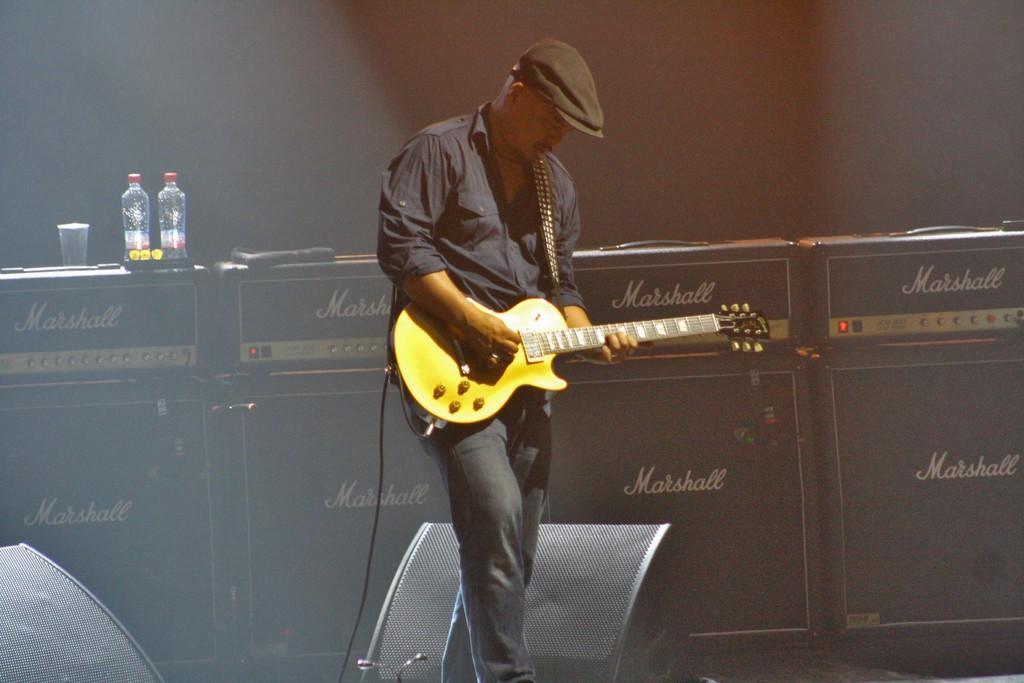In one or two sentences, can you explain what this image depicts? In this picture we can see a person in black dress and holding a guitar and behind him there is a desk on which there are same 